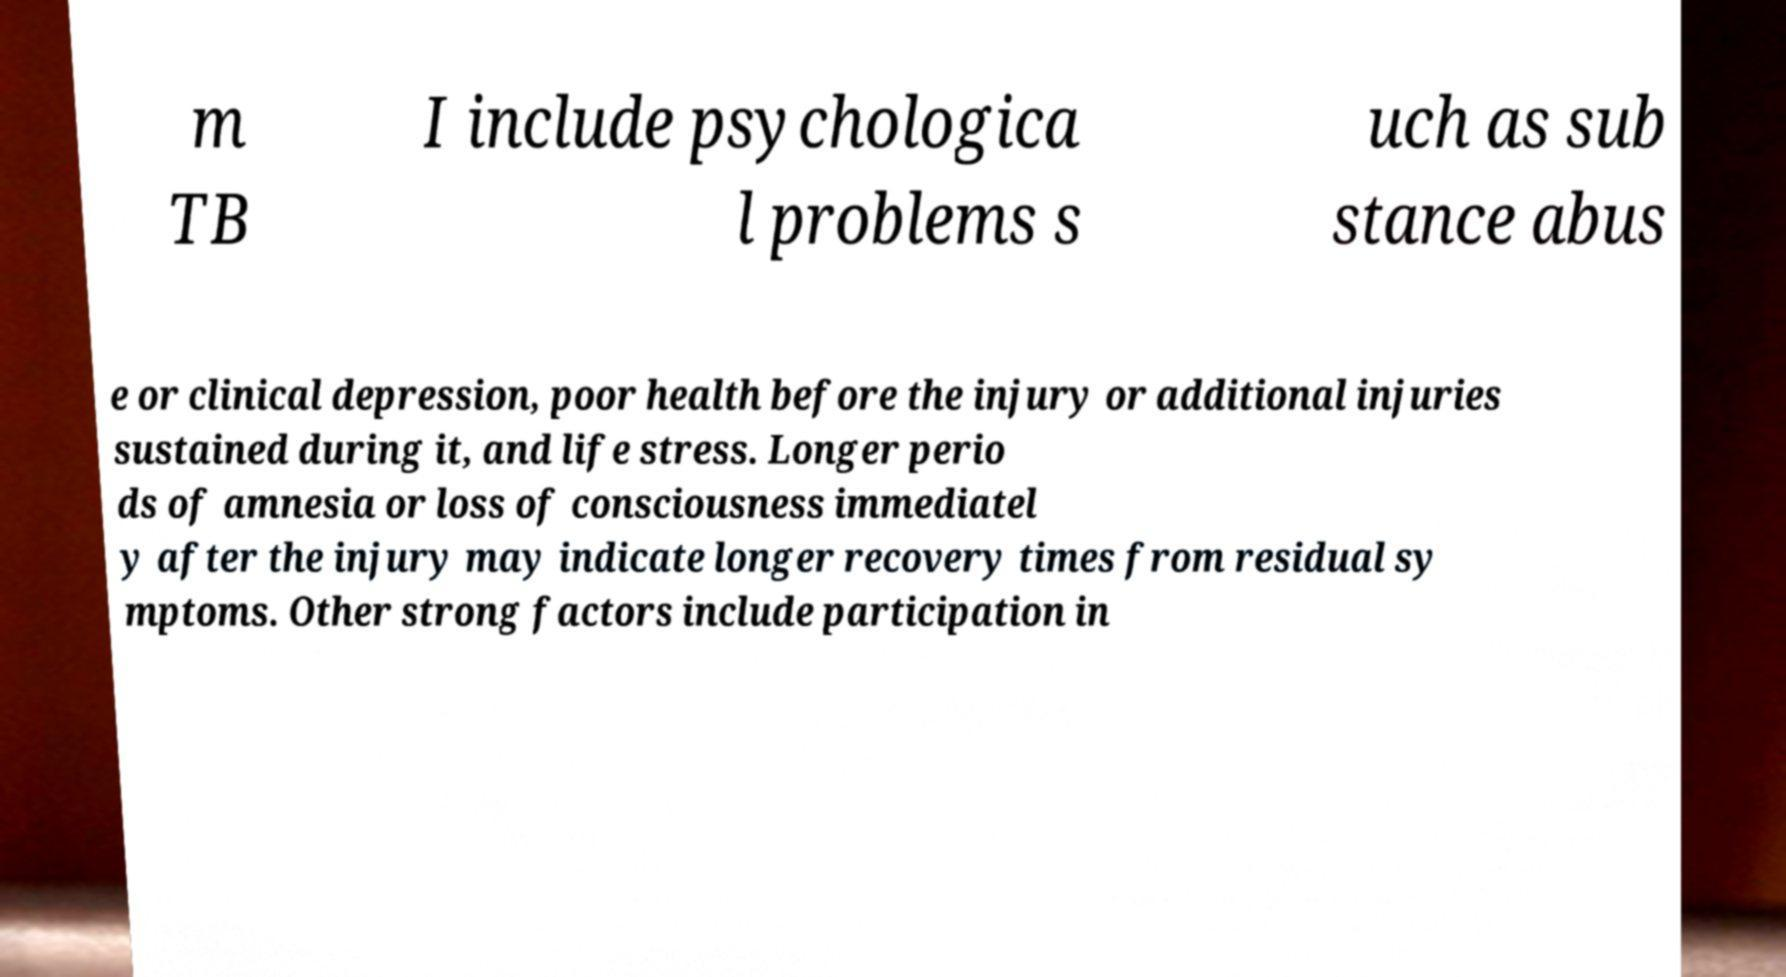What messages or text are displayed in this image? I need them in a readable, typed format. m TB I include psychologica l problems s uch as sub stance abus e or clinical depression, poor health before the injury or additional injuries sustained during it, and life stress. Longer perio ds of amnesia or loss of consciousness immediatel y after the injury may indicate longer recovery times from residual sy mptoms. Other strong factors include participation in 